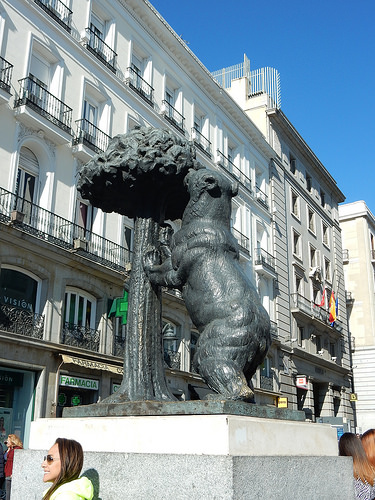<image>
Is there a building behind the statue? Yes. From this viewpoint, the building is positioned behind the statue, with the statue partially or fully occluding the building. 